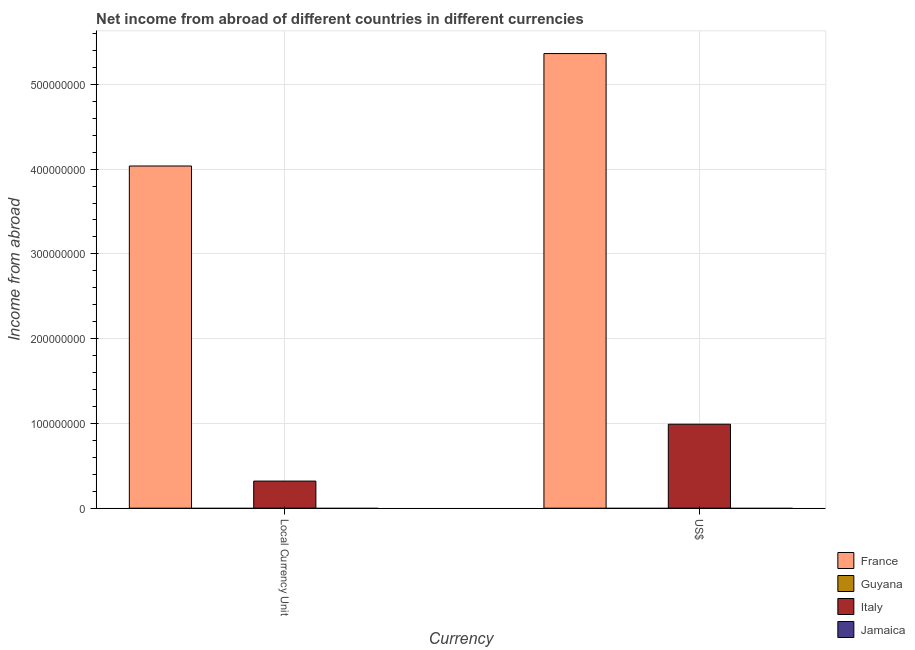Are the number of bars per tick equal to the number of legend labels?
Provide a short and direct response. No. Are the number of bars on each tick of the X-axis equal?
Offer a very short reply. Yes. How many bars are there on the 2nd tick from the left?
Your response must be concise. 2. How many bars are there on the 1st tick from the right?
Your answer should be very brief. 2. What is the label of the 1st group of bars from the left?
Make the answer very short. Local Currency Unit. Across all countries, what is the maximum income from abroad in us$?
Ensure brevity in your answer.  5.36e+08. Across all countries, what is the minimum income from abroad in constant 2005 us$?
Offer a very short reply. 0. In which country was the income from abroad in us$ maximum?
Your answer should be compact. France. What is the total income from abroad in us$ in the graph?
Offer a very short reply. 6.35e+08. What is the difference between the income from abroad in constant 2005 us$ in France and that in Italy?
Your answer should be compact. 3.72e+08. What is the difference between the income from abroad in us$ in France and the income from abroad in constant 2005 us$ in Jamaica?
Keep it short and to the point. 5.36e+08. What is the average income from abroad in us$ per country?
Give a very brief answer. 1.59e+08. What is the difference between the income from abroad in constant 2005 us$ and income from abroad in us$ in Italy?
Offer a very short reply. -6.71e+07. In how many countries, is the income from abroad in us$ greater than the average income from abroad in us$ taken over all countries?
Keep it short and to the point. 1. How many bars are there?
Make the answer very short. 4. Are the values on the major ticks of Y-axis written in scientific E-notation?
Offer a very short reply. No. Does the graph contain any zero values?
Give a very brief answer. Yes. Where does the legend appear in the graph?
Provide a short and direct response. Bottom right. How many legend labels are there?
Provide a short and direct response. 4. How are the legend labels stacked?
Your response must be concise. Vertical. What is the title of the graph?
Offer a very short reply. Net income from abroad of different countries in different currencies. What is the label or title of the X-axis?
Offer a terse response. Currency. What is the label or title of the Y-axis?
Offer a very short reply. Income from abroad. What is the Income from abroad of France in Local Currency Unit?
Provide a short and direct response. 4.04e+08. What is the Income from abroad in Guyana in Local Currency Unit?
Offer a very short reply. 0. What is the Income from abroad in Italy in Local Currency Unit?
Ensure brevity in your answer.  3.20e+07. What is the Income from abroad of France in US$?
Offer a very short reply. 5.36e+08. What is the Income from abroad in Guyana in US$?
Offer a very short reply. 0. What is the Income from abroad of Italy in US$?
Provide a short and direct response. 9.91e+07. Across all Currency, what is the maximum Income from abroad in France?
Your answer should be very brief. 5.36e+08. Across all Currency, what is the maximum Income from abroad in Italy?
Your response must be concise. 9.91e+07. Across all Currency, what is the minimum Income from abroad in France?
Offer a terse response. 4.04e+08. Across all Currency, what is the minimum Income from abroad of Italy?
Provide a short and direct response. 3.20e+07. What is the total Income from abroad in France in the graph?
Provide a succinct answer. 9.40e+08. What is the total Income from abroad in Italy in the graph?
Offer a terse response. 1.31e+08. What is the total Income from abroad of Jamaica in the graph?
Offer a terse response. 0. What is the difference between the Income from abroad of France in Local Currency Unit and that in US$?
Your answer should be compact. -1.33e+08. What is the difference between the Income from abroad of Italy in Local Currency Unit and that in US$?
Provide a short and direct response. -6.71e+07. What is the difference between the Income from abroad in France in Local Currency Unit and the Income from abroad in Italy in US$?
Provide a short and direct response. 3.05e+08. What is the average Income from abroad of France per Currency?
Your answer should be compact. 4.70e+08. What is the average Income from abroad of Guyana per Currency?
Provide a succinct answer. 0. What is the average Income from abroad in Italy per Currency?
Your answer should be very brief. 6.55e+07. What is the difference between the Income from abroad in France and Income from abroad in Italy in Local Currency Unit?
Your answer should be very brief. 3.72e+08. What is the difference between the Income from abroad in France and Income from abroad in Italy in US$?
Keep it short and to the point. 4.37e+08. What is the ratio of the Income from abroad of France in Local Currency Unit to that in US$?
Offer a very short reply. 0.75. What is the ratio of the Income from abroad in Italy in Local Currency Unit to that in US$?
Give a very brief answer. 0.32. What is the difference between the highest and the second highest Income from abroad of France?
Your response must be concise. 1.33e+08. What is the difference between the highest and the second highest Income from abroad in Italy?
Your answer should be compact. 6.71e+07. What is the difference between the highest and the lowest Income from abroad in France?
Make the answer very short. 1.33e+08. What is the difference between the highest and the lowest Income from abroad of Italy?
Offer a terse response. 6.71e+07. 